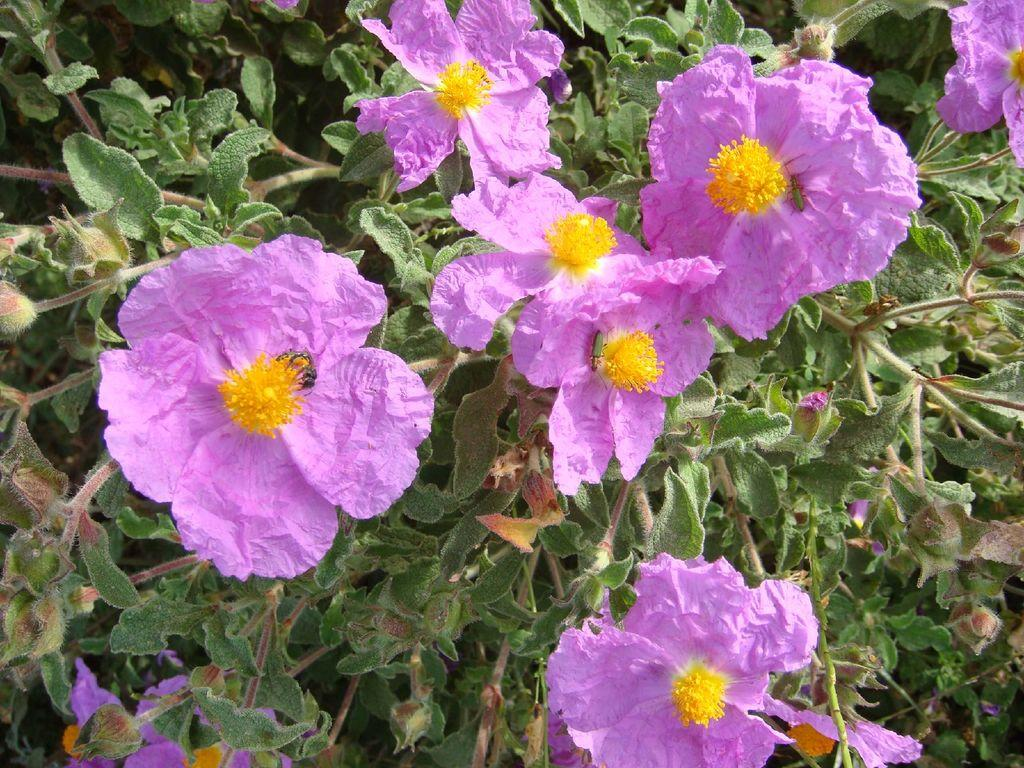What is the main subject of the image? The main subject of the image is plants. Where are the plants located in the image? The plants are in the center of the image. What additional feature can be observed on the plants? The plants have flowers. What colors are the flowers? The flowers are in pink and yellow colors. How many pies are being sold by the rabbits in the image? There are no rabbits or pies present in the image. What is the profit margin for the flowers in the image? There is no information about profit margins in the image, as it only shows plants with flowers. 